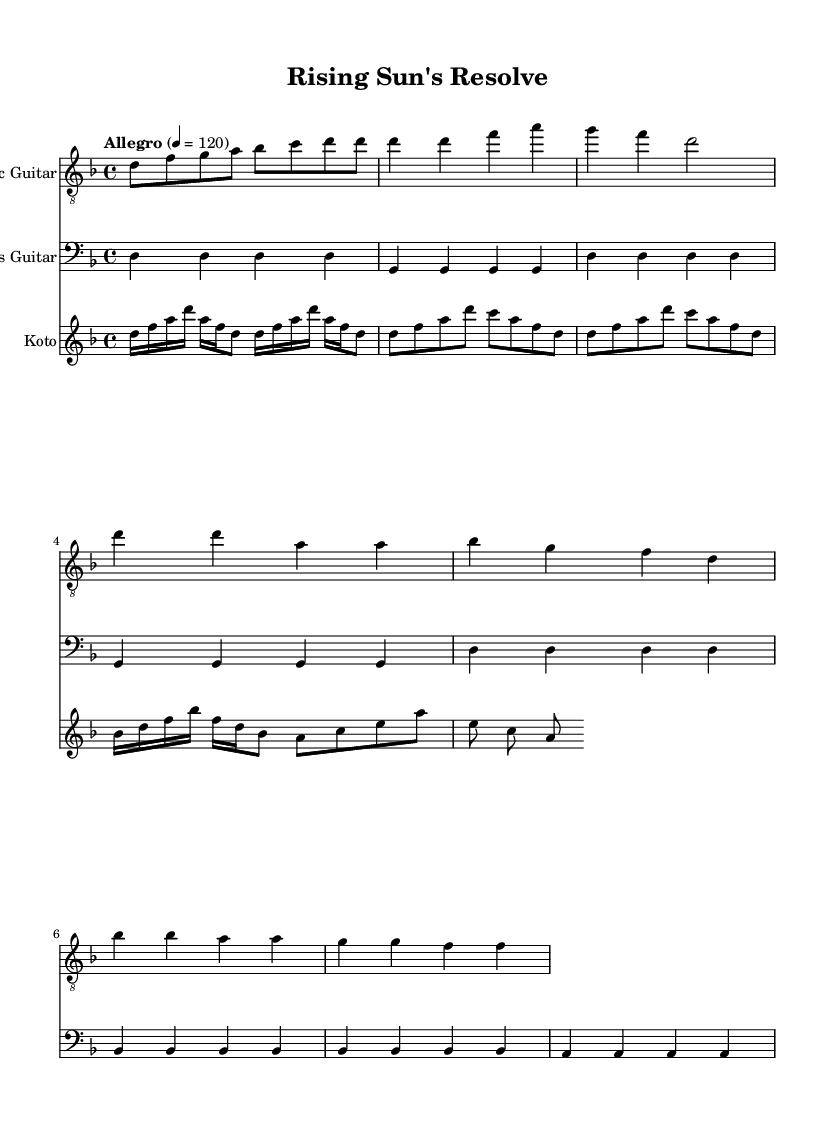What is the key signature of this music? The key signature indicates one flat, which corresponds to the key of D minor.
Answer: D minor What is the time signature of this music? The time signature is shown at the beginning of the score and indicates that there are four beats per measure.
Answer: 4/4 What is the indicated tempo of this piece? The tempo marking in the music states "Allegro" and specifies a speed of 120 beats per minute.
Answer: 120 How many sections are indicated in the electric guitar part? The electric guitar part has an intro, followed by a verse, a chorus, and a bridge, indicating four distinct sections.
Answer: Four Which instrument has a simplified bass line? The bass guitar section is noted for having a simplified bass line, contrasting with more complex arrangements for other instruments.
Answer: Bass Guitar What is the highest pitch shown in the koto part? Observing the koto part, the highest pitch notated is 'a', which appears several times in the sections specified.
Answer: 'a' Which instrument is playing an arpeggio in the intro? The koto part indicates that the instrument is playing an arpeggio at the beginning, which is characteristic of traditional Japanese music.
Answer: Koto 